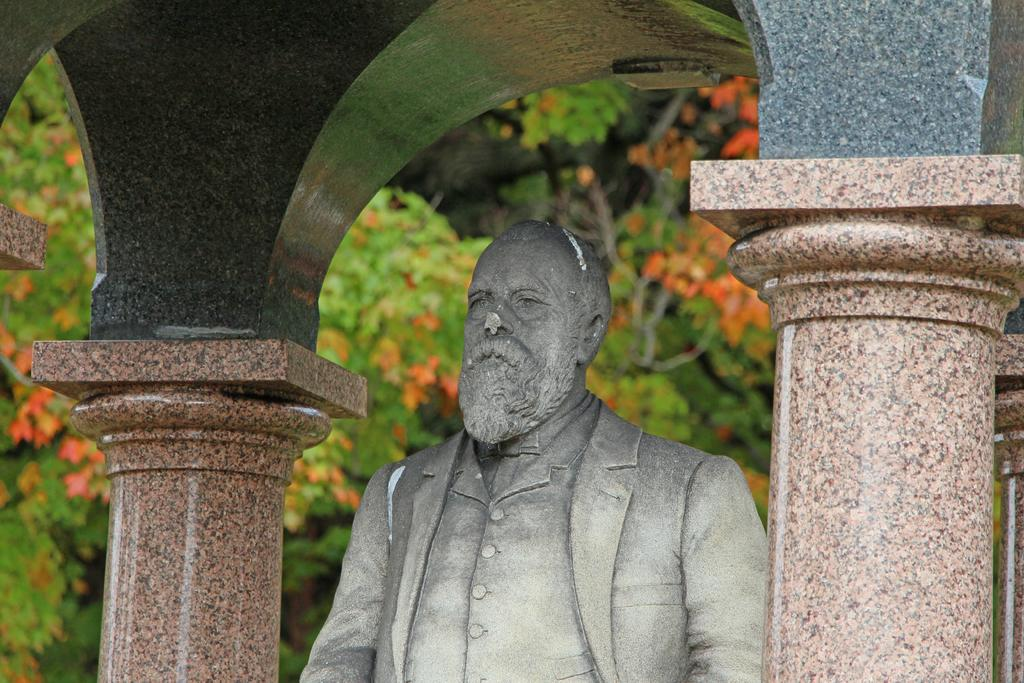What is the main subject in the image? There is a statue of a person in the image. What can be seen in the background of the image? There are trees in the background of the image. How many stars are visible on the statue in the image? There are no stars present on the statue in the image. 